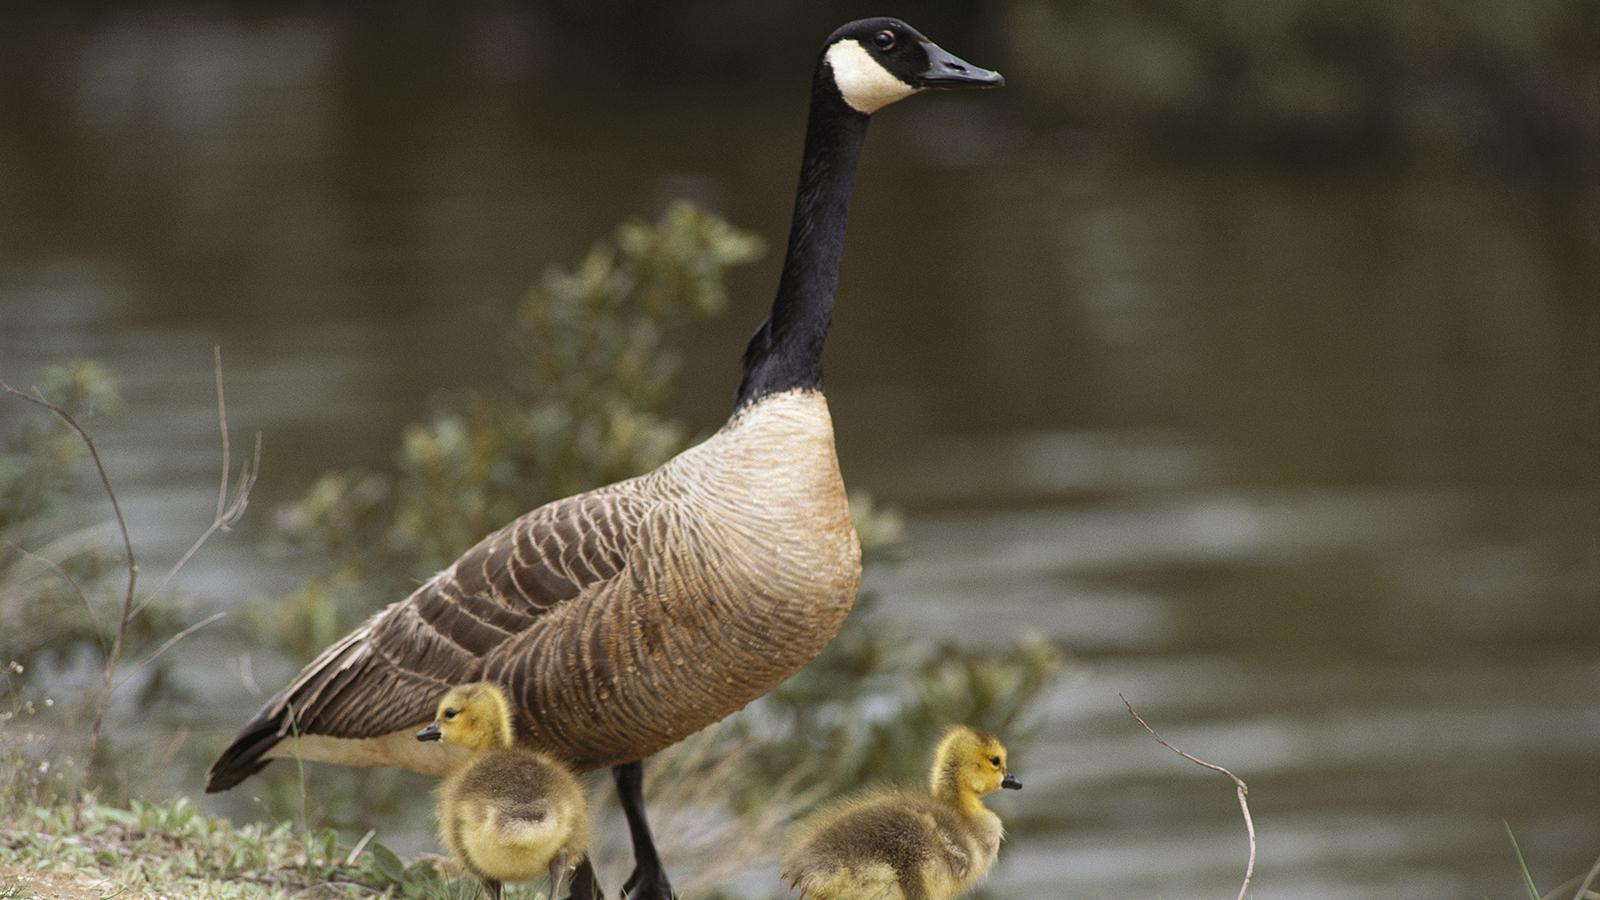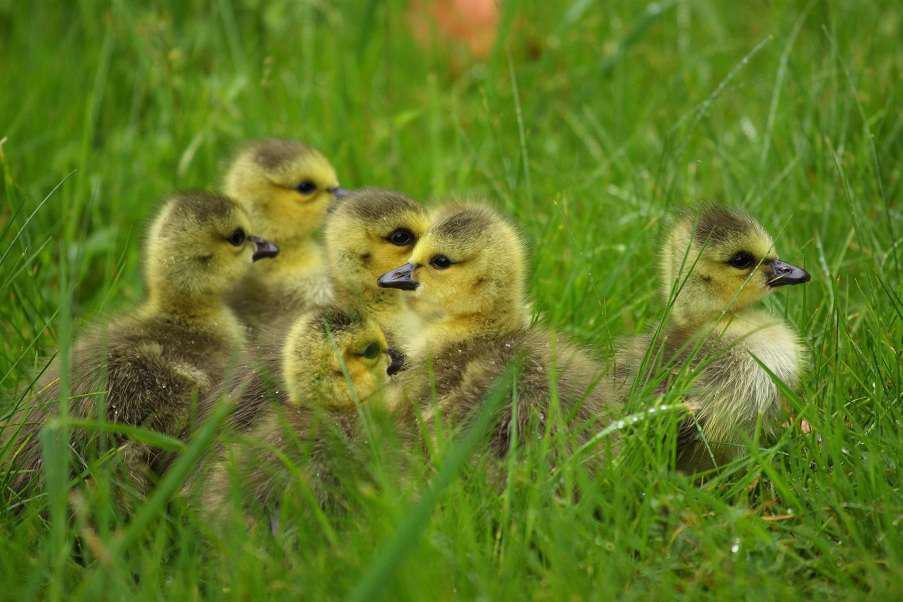The first image is the image on the left, the second image is the image on the right. Given the left and right images, does the statement "two parents are swimming with their baby geese." hold true? Answer yes or no. No. The first image is the image on the left, the second image is the image on the right. For the images displayed, is the sentence "The ducks are swimming in at least one of the images." factually correct? Answer yes or no. No. 